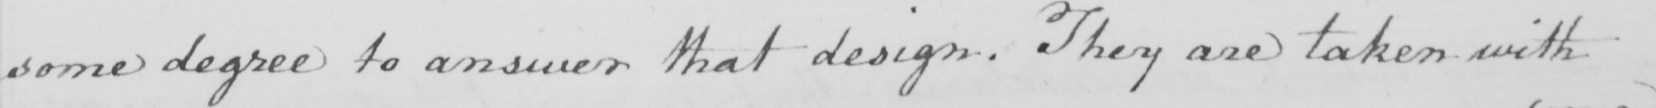Please transcribe the handwritten text in this image. some degree to answer that design. They are taken with 